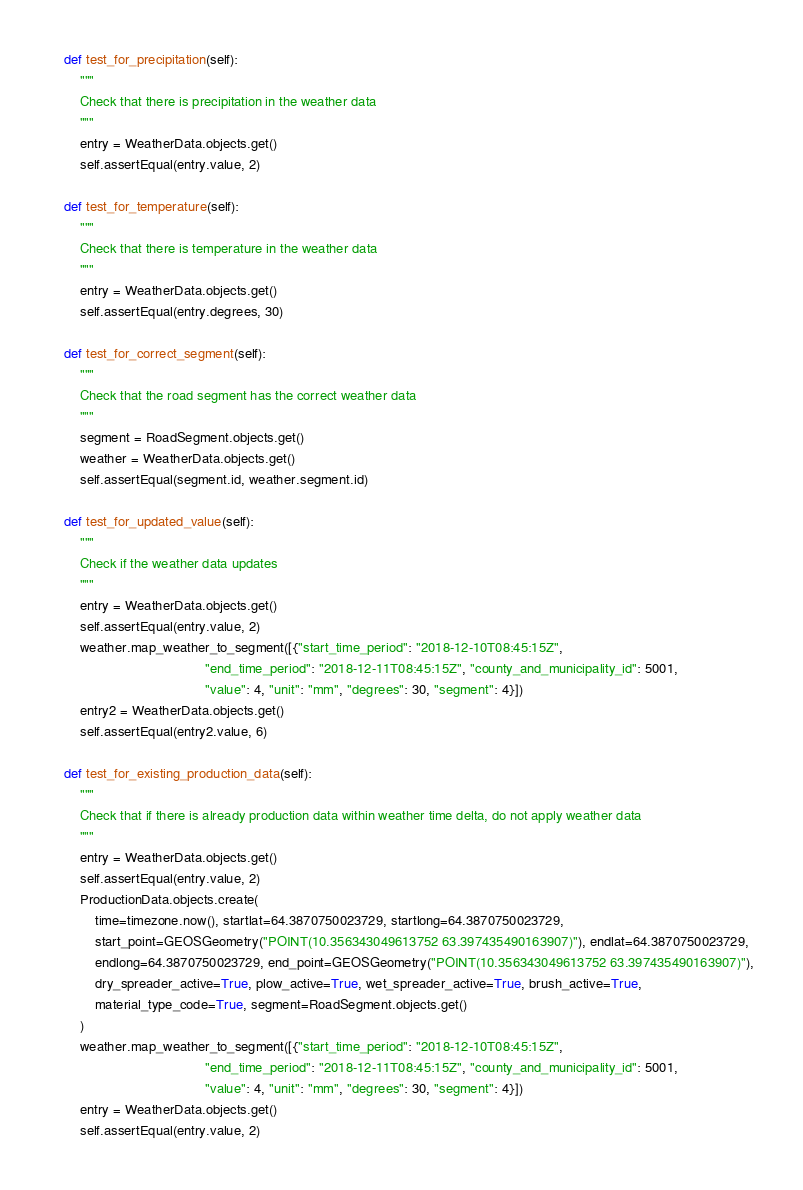<code> <loc_0><loc_0><loc_500><loc_500><_Python_>    def test_for_precipitation(self):
        """
        Check that there is precipitation in the weather data
        """
        entry = WeatherData.objects.get()
        self.assertEqual(entry.value, 2)

    def test_for_temperature(self):
        """
        Check that there is temperature in the weather data
        """
        entry = WeatherData.objects.get()
        self.assertEqual(entry.degrees, 30)

    def test_for_correct_segment(self):
        """
        Check that the road segment has the correct weather data
        """
        segment = RoadSegment.objects.get()
        weather = WeatherData.objects.get()
        self.assertEqual(segment.id, weather.segment.id)

    def test_for_updated_value(self):
        """
        Check if the weather data updates
        """
        entry = WeatherData.objects.get()
        self.assertEqual(entry.value, 2)
        weather.map_weather_to_segment([{"start_time_period": "2018-12-10T08:45:15Z",
                                         "end_time_period": "2018-12-11T08:45:15Z", "county_and_municipality_id": 5001,
                                         "value": 4, "unit": "mm", "degrees": 30, "segment": 4}])
        entry2 = WeatherData.objects.get()
        self.assertEqual(entry2.value, 6)

    def test_for_existing_production_data(self):
        """
        Check that if there is already production data within weather time delta, do not apply weather data
        """
        entry = WeatherData.objects.get()
        self.assertEqual(entry.value, 2)
        ProductionData.objects.create(
            time=timezone.now(), startlat=64.3870750023729, startlong=64.3870750023729,
            start_point=GEOSGeometry("POINT(10.356343049613752 63.397435490163907)"), endlat=64.3870750023729,
            endlong=64.3870750023729, end_point=GEOSGeometry("POINT(10.356343049613752 63.397435490163907)"),
            dry_spreader_active=True, plow_active=True, wet_spreader_active=True, brush_active=True,
            material_type_code=True, segment=RoadSegment.objects.get()
        )
        weather.map_weather_to_segment([{"start_time_period": "2018-12-10T08:45:15Z",
                                         "end_time_period": "2018-12-11T08:45:15Z", "county_and_municipality_id": 5001,
                                         "value": 4, "unit": "mm", "degrees": 30, "segment": 4}])
        entry = WeatherData.objects.get()
        self.assertEqual(entry.value, 2)
</code> 